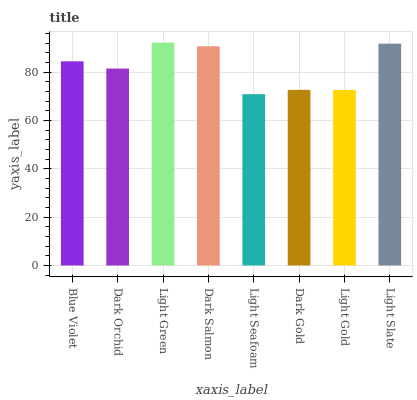Is Light Seafoam the minimum?
Answer yes or no. Yes. Is Light Green the maximum?
Answer yes or no. Yes. Is Dark Orchid the minimum?
Answer yes or no. No. Is Dark Orchid the maximum?
Answer yes or no. No. Is Blue Violet greater than Dark Orchid?
Answer yes or no. Yes. Is Dark Orchid less than Blue Violet?
Answer yes or no. Yes. Is Dark Orchid greater than Blue Violet?
Answer yes or no. No. Is Blue Violet less than Dark Orchid?
Answer yes or no. No. Is Blue Violet the high median?
Answer yes or no. Yes. Is Dark Orchid the low median?
Answer yes or no. Yes. Is Light Green the high median?
Answer yes or no. No. Is Light Slate the low median?
Answer yes or no. No. 